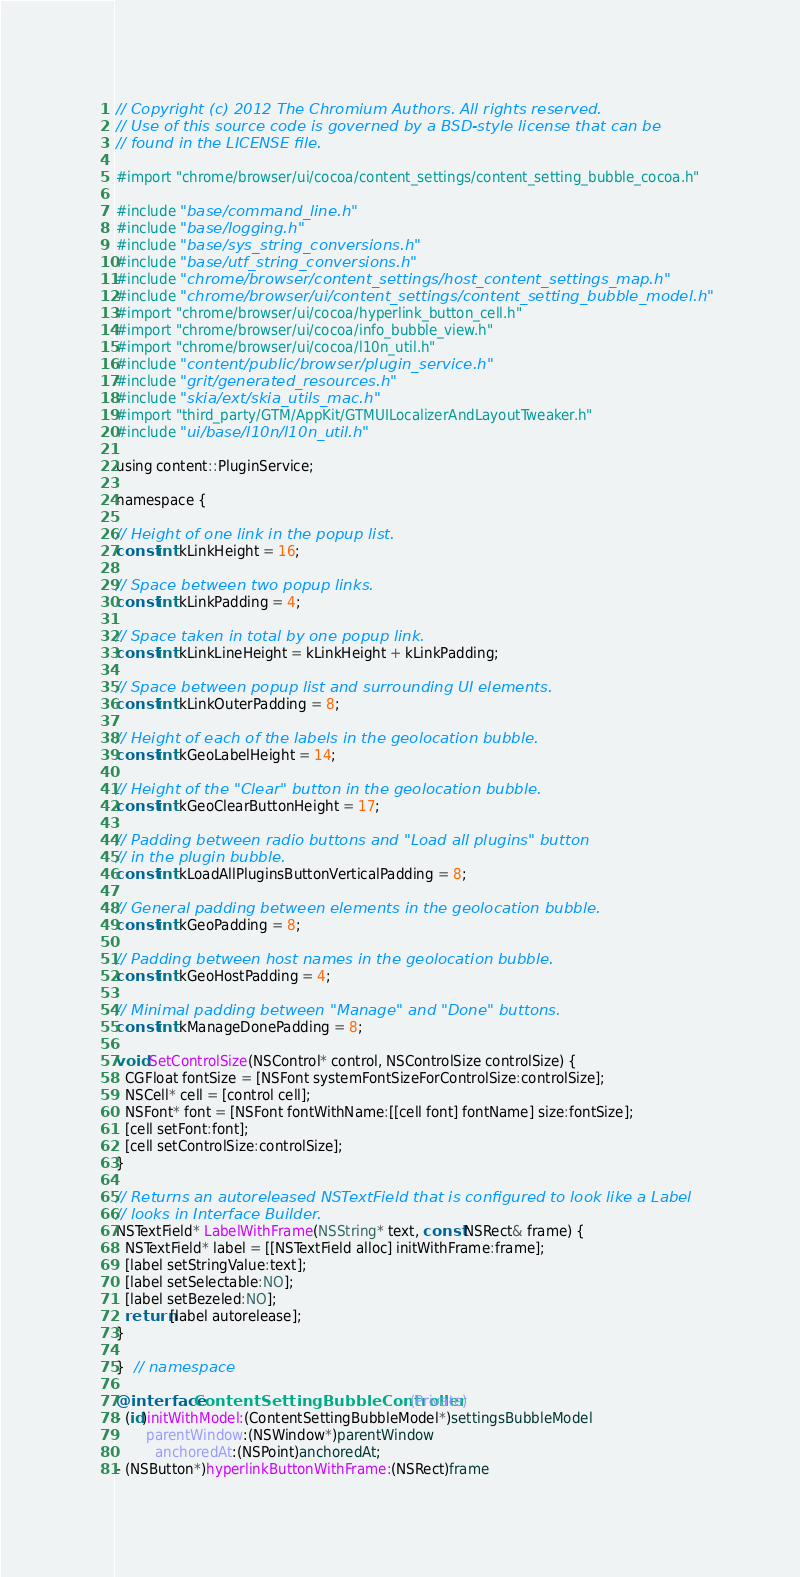Convert code to text. <code><loc_0><loc_0><loc_500><loc_500><_ObjectiveC_>// Copyright (c) 2012 The Chromium Authors. All rights reserved.
// Use of this source code is governed by a BSD-style license that can be
// found in the LICENSE file.

#import "chrome/browser/ui/cocoa/content_settings/content_setting_bubble_cocoa.h"

#include "base/command_line.h"
#include "base/logging.h"
#include "base/sys_string_conversions.h"
#include "base/utf_string_conversions.h"
#include "chrome/browser/content_settings/host_content_settings_map.h"
#include "chrome/browser/ui/content_settings/content_setting_bubble_model.h"
#import "chrome/browser/ui/cocoa/hyperlink_button_cell.h"
#import "chrome/browser/ui/cocoa/info_bubble_view.h"
#import "chrome/browser/ui/cocoa/l10n_util.h"
#include "content/public/browser/plugin_service.h"
#include "grit/generated_resources.h"
#include "skia/ext/skia_utils_mac.h"
#import "third_party/GTM/AppKit/GTMUILocalizerAndLayoutTweaker.h"
#include "ui/base/l10n/l10n_util.h"

using content::PluginService;

namespace {

// Height of one link in the popup list.
const int kLinkHeight = 16;

// Space between two popup links.
const int kLinkPadding = 4;

// Space taken in total by one popup link.
const int kLinkLineHeight = kLinkHeight + kLinkPadding;

// Space between popup list and surrounding UI elements.
const int kLinkOuterPadding = 8;

// Height of each of the labels in the geolocation bubble.
const int kGeoLabelHeight = 14;

// Height of the "Clear" button in the geolocation bubble.
const int kGeoClearButtonHeight = 17;

// Padding between radio buttons and "Load all plugins" button
// in the plugin bubble.
const int kLoadAllPluginsButtonVerticalPadding = 8;

// General padding between elements in the geolocation bubble.
const int kGeoPadding = 8;

// Padding between host names in the geolocation bubble.
const int kGeoHostPadding = 4;

// Minimal padding between "Manage" and "Done" buttons.
const int kManageDonePadding = 8;

void SetControlSize(NSControl* control, NSControlSize controlSize) {
  CGFloat fontSize = [NSFont systemFontSizeForControlSize:controlSize];
  NSCell* cell = [control cell];
  NSFont* font = [NSFont fontWithName:[[cell font] fontName] size:fontSize];
  [cell setFont:font];
  [cell setControlSize:controlSize];
}

// Returns an autoreleased NSTextField that is configured to look like a Label
// looks in Interface Builder.
NSTextField* LabelWithFrame(NSString* text, const NSRect& frame) {
  NSTextField* label = [[NSTextField alloc] initWithFrame:frame];
  [label setStringValue:text];
  [label setSelectable:NO];
  [label setBezeled:NO];
  return [label autorelease];
}

}  // namespace

@interface ContentSettingBubbleController(Private)
- (id)initWithModel:(ContentSettingBubbleModel*)settingsBubbleModel
       parentWindow:(NSWindow*)parentWindow
         anchoredAt:(NSPoint)anchoredAt;
- (NSButton*)hyperlinkButtonWithFrame:(NSRect)frame</code> 